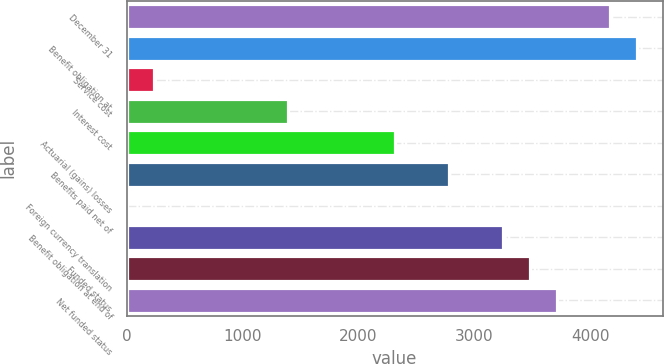Convert chart. <chart><loc_0><loc_0><loc_500><loc_500><bar_chart><fcel>December 31<fcel>Benefit obligation at<fcel>Service cost<fcel>Interest cost<fcel>Actuarial (gains) losses<fcel>Benefits paid net of<fcel>Foreign currency translation<fcel>Benefit obligation at end of<fcel>Funded status<fcel>Net funded status<nl><fcel>4173.4<fcel>4405.2<fcel>232.8<fcel>1391.8<fcel>2319<fcel>2782.6<fcel>1<fcel>3246.2<fcel>3478<fcel>3709.8<nl></chart> 